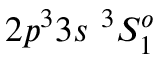Convert formula to latex. <formula><loc_0><loc_0><loc_500><loc_500>{ 2 p ^ { 3 } 3 s ^ { 3 } S _ { 1 } ^ { o } }</formula> 